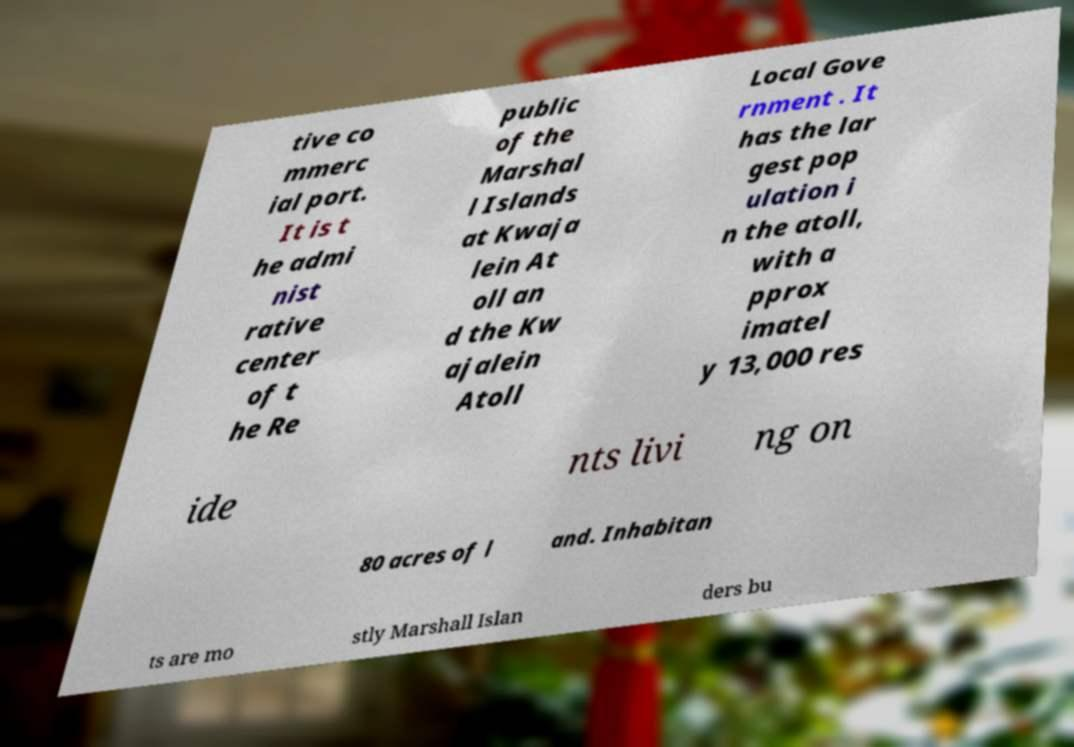Can you read and provide the text displayed in the image?This photo seems to have some interesting text. Can you extract and type it out for me? tive co mmerc ial port. It is t he admi nist rative center of t he Re public of the Marshal l Islands at Kwaja lein At oll an d the Kw ajalein Atoll Local Gove rnment . It has the lar gest pop ulation i n the atoll, with a pprox imatel y 13,000 res ide nts livi ng on 80 acres of l and. Inhabitan ts are mo stly Marshall Islan ders bu 